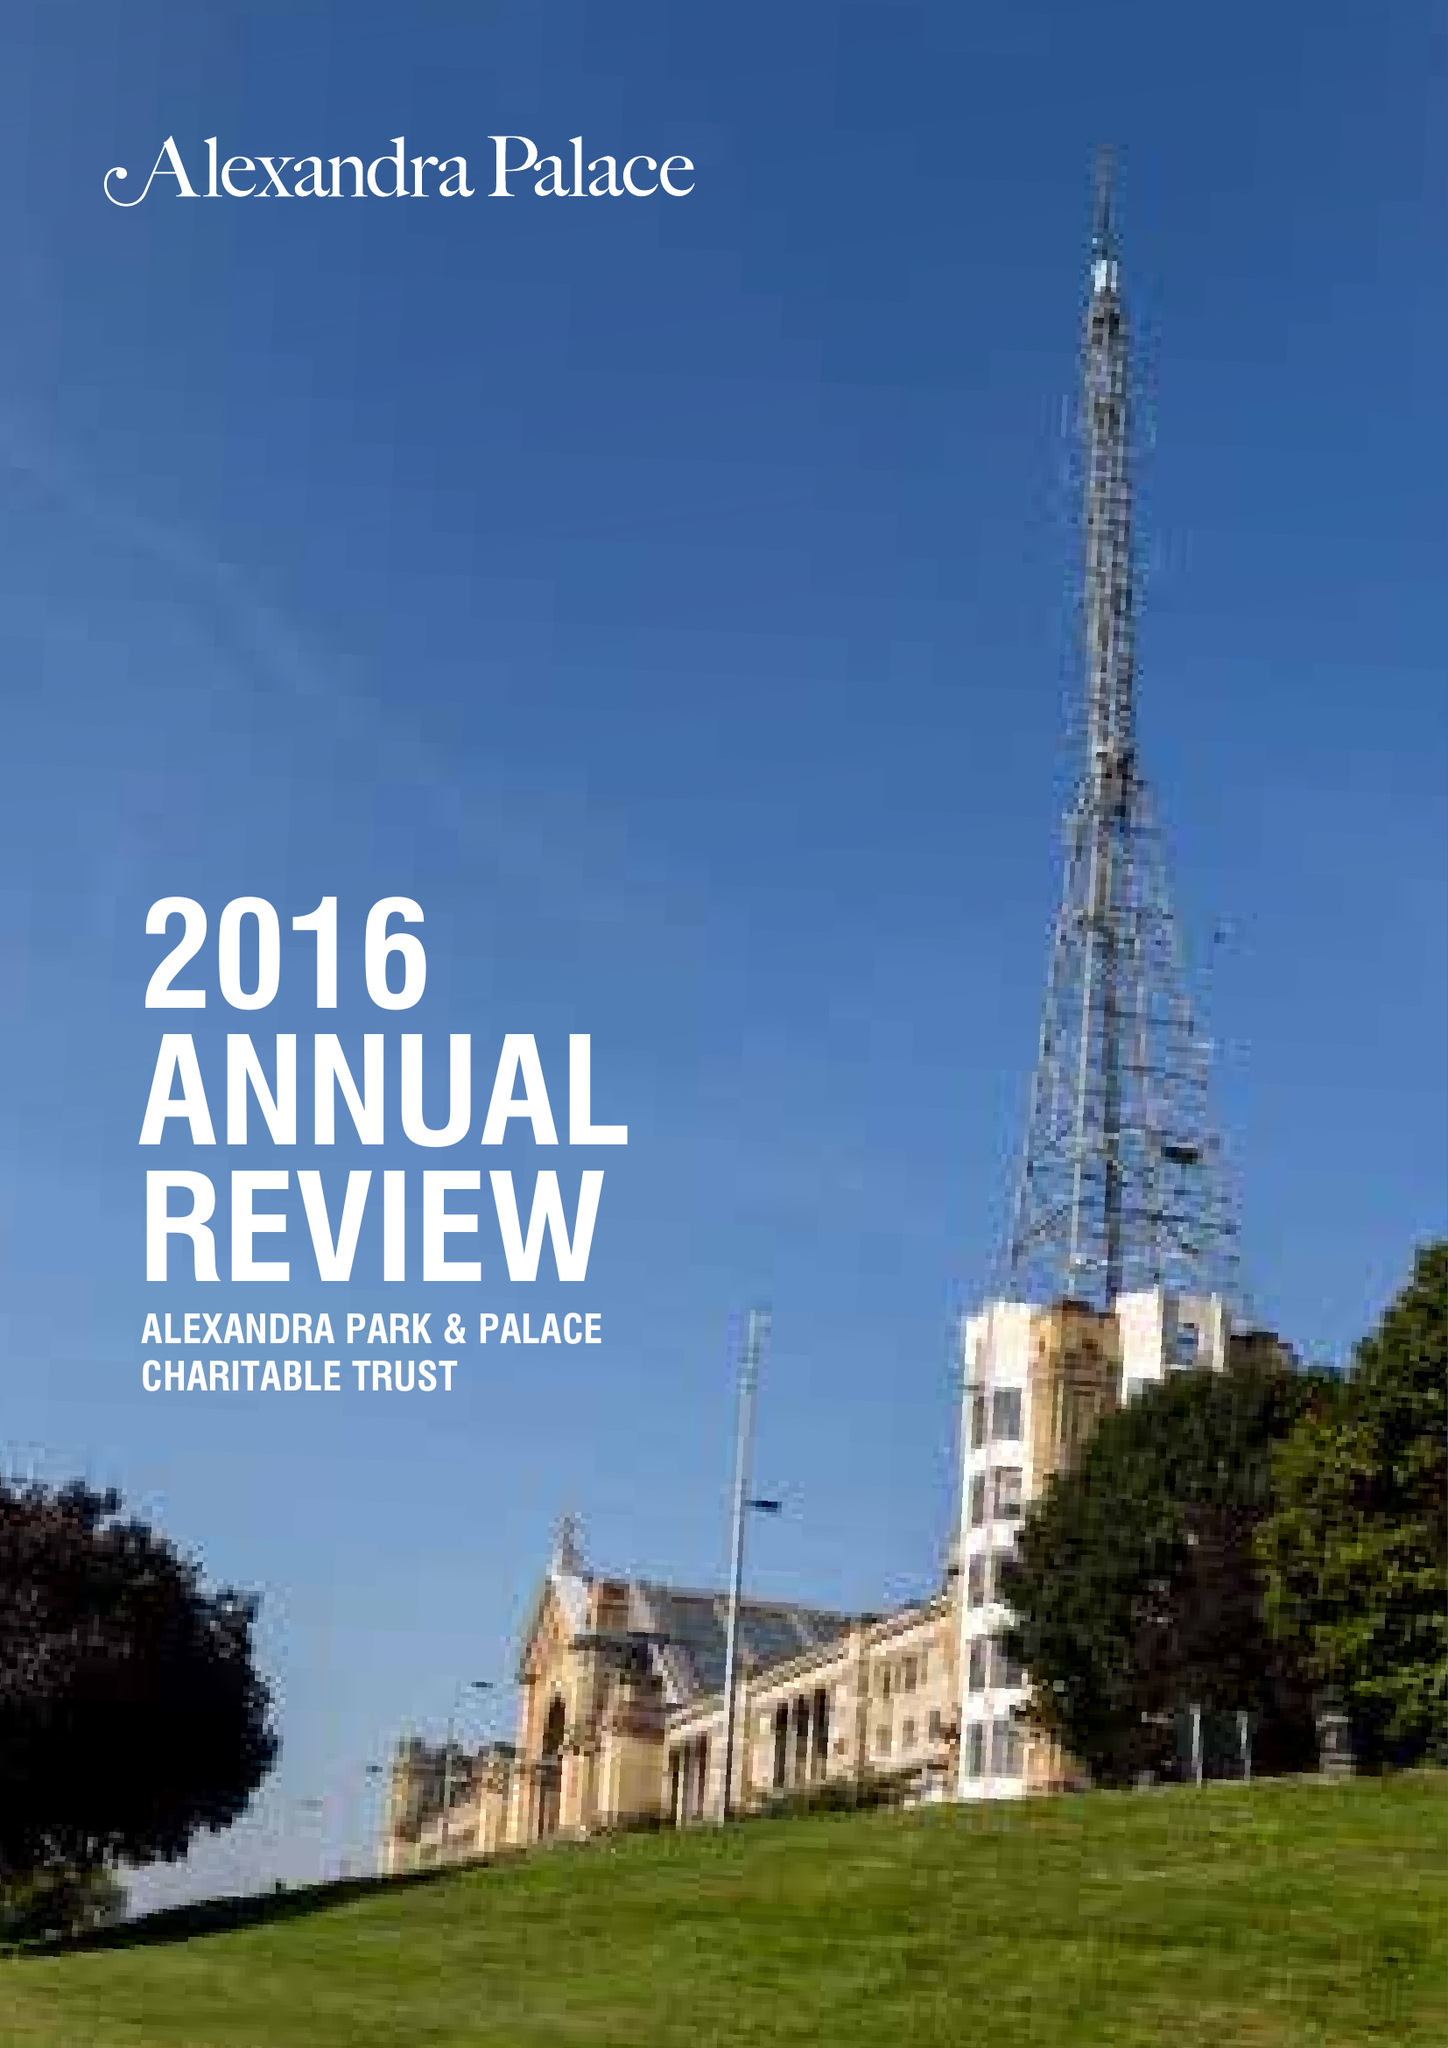What is the value for the address__street_line?
Answer the question using a single word or phrase. ALEXANDRA PALACE WAY 